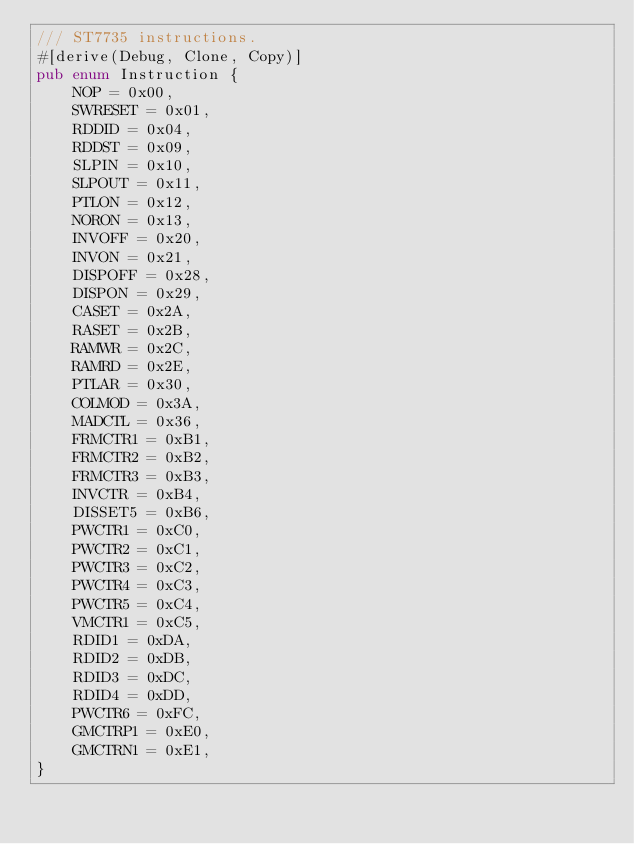<code> <loc_0><loc_0><loc_500><loc_500><_Rust_>/// ST7735 instructions.
#[derive(Debug, Clone, Copy)]
pub enum Instruction {
    NOP = 0x00,
    SWRESET = 0x01,
    RDDID = 0x04,
    RDDST = 0x09,
    SLPIN = 0x10,
    SLPOUT = 0x11,
    PTLON = 0x12,
    NORON = 0x13,
    INVOFF = 0x20,
    INVON = 0x21,
    DISPOFF = 0x28,
    DISPON = 0x29,
    CASET = 0x2A,
    RASET = 0x2B,
    RAMWR = 0x2C,
    RAMRD = 0x2E,
    PTLAR = 0x30,
    COLMOD = 0x3A,
    MADCTL = 0x36,
    FRMCTR1 = 0xB1,
    FRMCTR2 = 0xB2,
    FRMCTR3 = 0xB3,
    INVCTR = 0xB4,
    DISSET5 = 0xB6,
    PWCTR1 = 0xC0,
    PWCTR2 = 0xC1,
    PWCTR3 = 0xC2,
    PWCTR4 = 0xC3,
    PWCTR5 = 0xC4,
    VMCTR1 = 0xC5,
    RDID1 = 0xDA,
    RDID2 = 0xDB,
    RDID3 = 0xDC,
    RDID4 = 0xDD,
    PWCTR6 = 0xFC,
    GMCTRP1 = 0xE0,
    GMCTRN1 = 0xE1,
}
</code> 